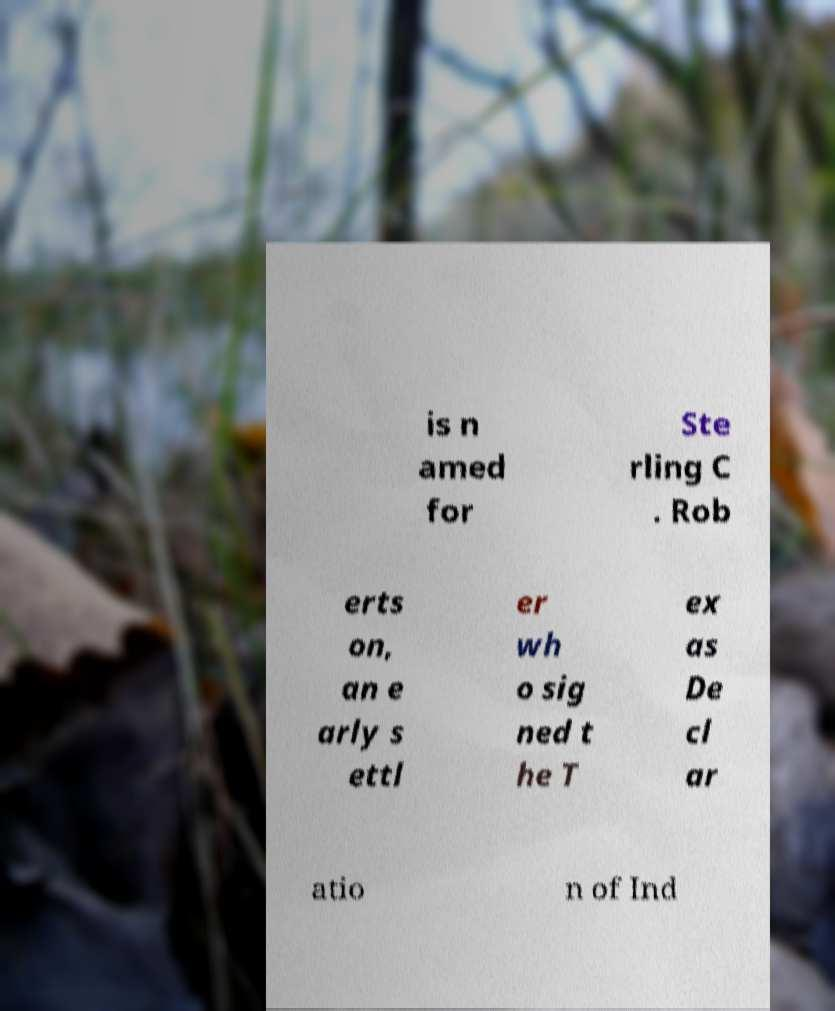Can you read and provide the text displayed in the image?This photo seems to have some interesting text. Can you extract and type it out for me? is n amed for Ste rling C . Rob erts on, an e arly s ettl er wh o sig ned t he T ex as De cl ar atio n of Ind 